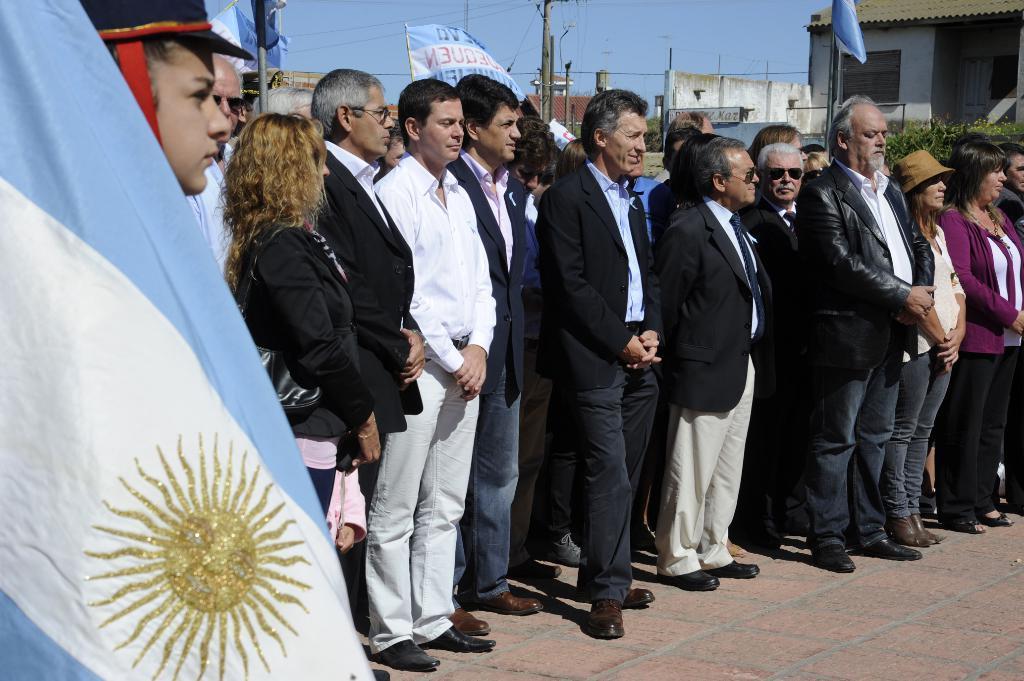How would you summarize this image in a sentence or two? In the picture we can see some people are standing on the path and besides them, we can see some flag which is white and blue in color and in the background also we can see some flags, poles, buildings and sky. 